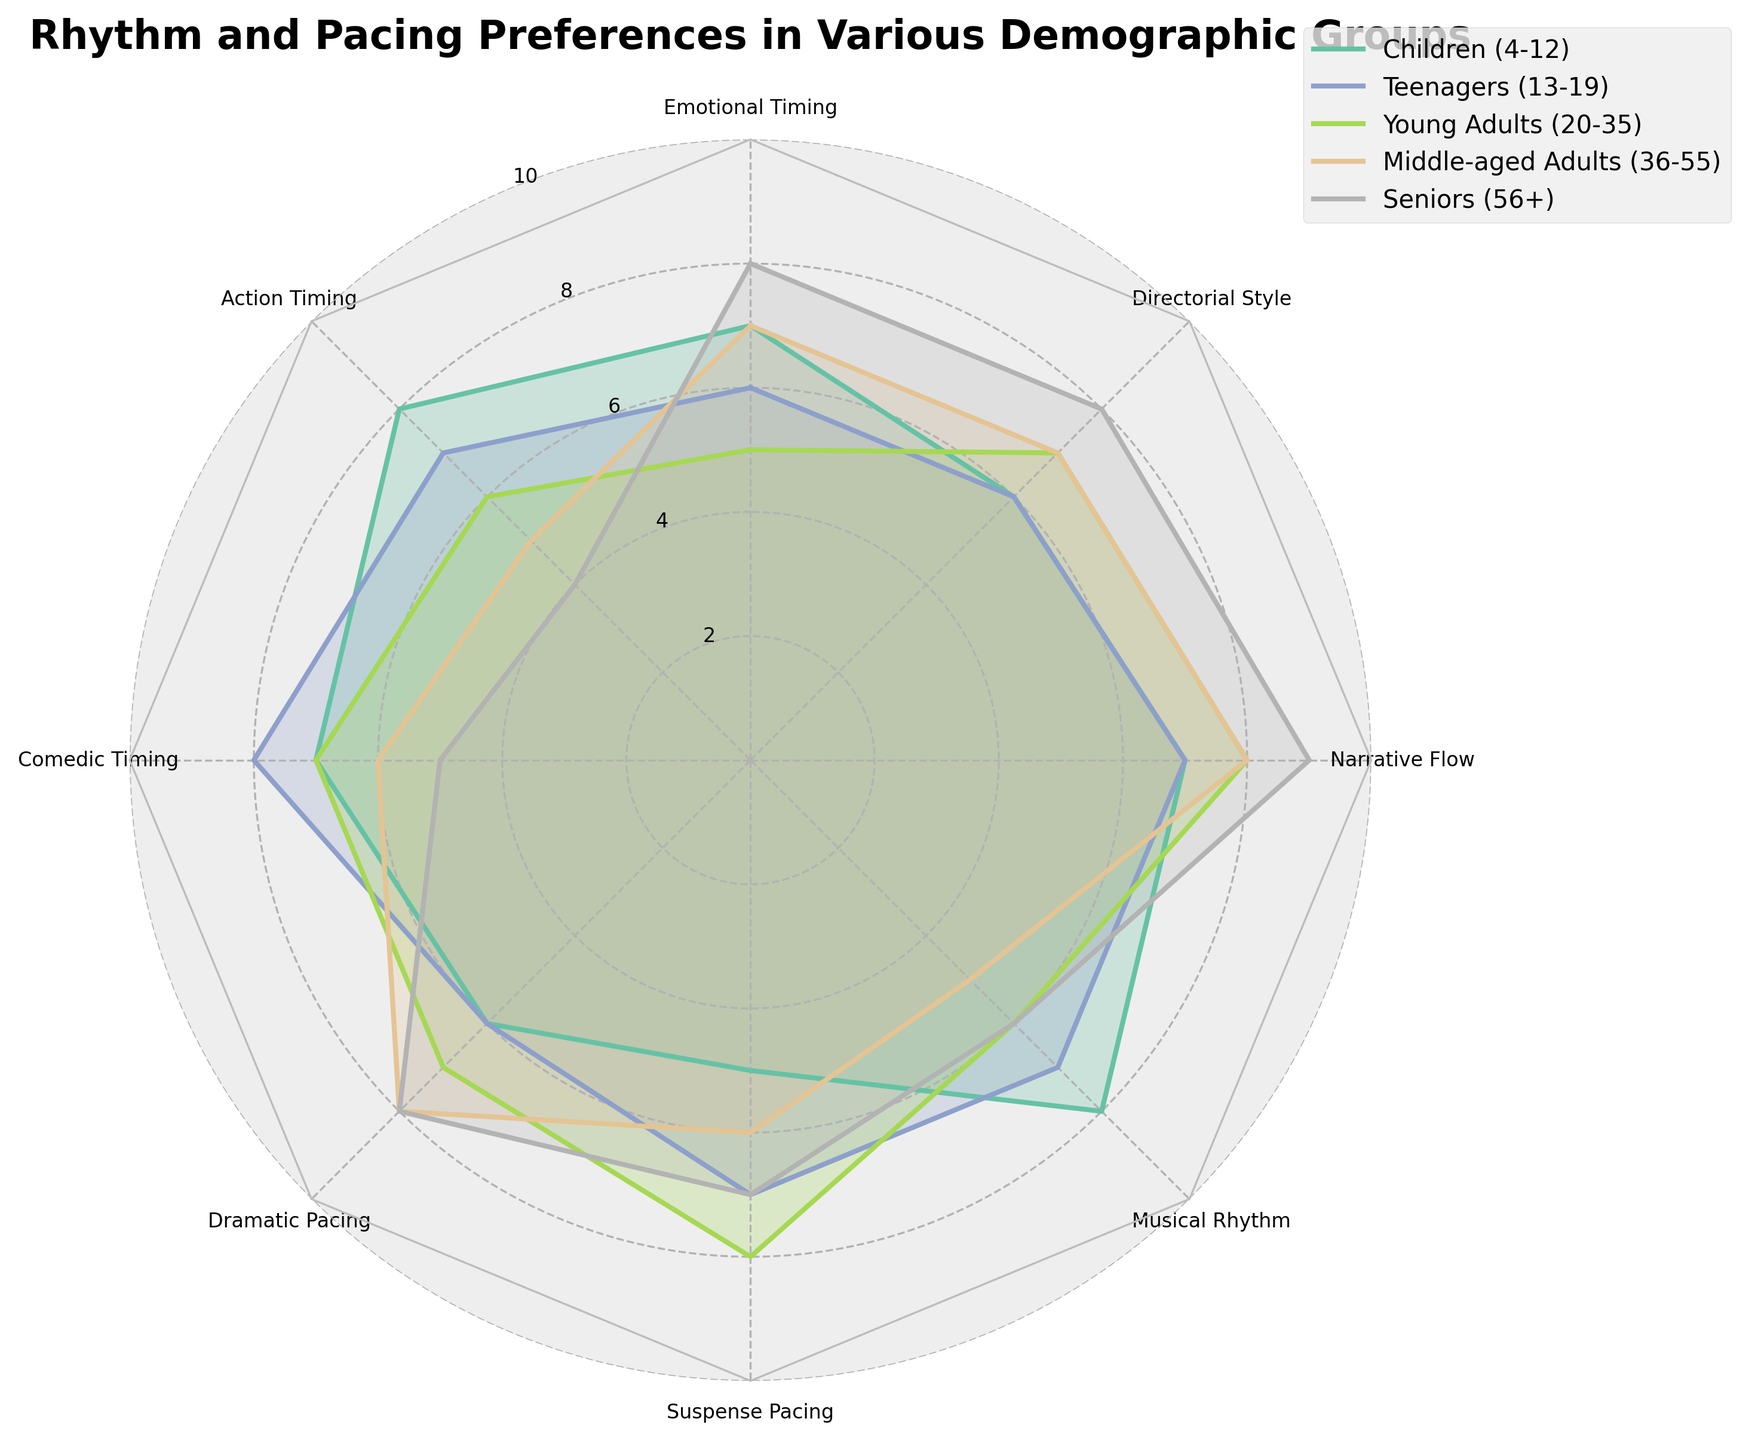what is the title of the figure? The title of the figure is typically placed at the top and is meant to give a concise description of what the figure is about. By examining the figure's header text, we identify the title.
Answer: Rhythm and Pacing Preferences in Various Demographic Groups Which demographic group has the highest preference for Emotional Timing? By looking at the data points for Emotional Timing category for each demographic group, we find the highest value among them. The Seniors (56+) group has an 8 for Emotional Timing, which is the highest.
Answer: Seniors (56+) Which demographic group rates Action Timing the lowest? By examining the data points corresponding to Action Timing for each demographic group, the Seniors (56+) group has the lowest value of 4.
Answer: Seniors (56+) Compare the preferences for Comedic Timing between Teenagers and Middle-aged Adults. Which group prefers it more? By comparing the values for Comedic Timing, Teenagers have a rating of 8, while Middle-aged Adults have a rating of 6. Therefore, Teenagers prefer Comedic Timing more.
Answer: Teenagers Identify the category where Middle-aged Adults and Seniors have the same preference. Check all category values for both Middle-aged Adults and Seniors. In Dramatic Pacing, both have a value of 8.
Answer: Dramatic Pacing What's the average rating for Narrative Flow across all demographic groups? Add up the values for Narrative Flow from each group (7 + 7 + 8 + 8 + 9 = 39). Then divide by the number of groups (5): 39 / 5 = 7.8.
Answer: 7.8 Which group has the highest average preference across all categories? Sum the values for each demographic group and divide by the number of categories (8). Children: (7+8+7+6+5+8+7+6)/8 = 6.75, Teenagers: (6+7+8+6+7+7+7+6)/8 = 6.75, Young Adults: (5+6+7+7+8+6+8+7)/8 = 6.75, Middle-aged Adults: (7+5+6+8+6+5+8+7)/8 = 6.5, Seniors: (8+4+5+8+7+6+9+8)/8 = 6.875. So the group with the highest average preference is Seniors (56+).
Answer: Seniors (56+) What is the difference between the highest and lowest rating for Musical Rhythm across all groups? The highest rating for Musical Rhythm is 8 (Children) and the lowest is 5 (Middle-aged Adults). The difference is 8 - 5 = 3.
Answer: 3 Do Teens or Young Adults have a higher preference for Suspense Pacing? Compare the Suspense Pacing values for both groups. Teens have a rating of 7, whereas Young Adults have a rating of 8. Thus, Young Adults have a higher preference.
Answer: Young Adults 